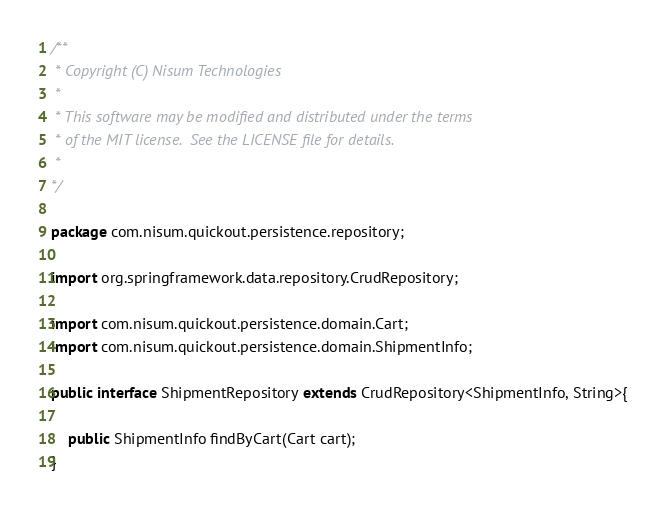Convert code to text. <code><loc_0><loc_0><loc_500><loc_500><_Java_>/**
 * Copyright (C) Nisum Technologies
 *
 * This software may be modified and distributed under the terms
 * of the MIT license.  See the LICENSE file for details.
 * 
*/

package com.nisum.quickout.persistence.repository;

import org.springframework.data.repository.CrudRepository;

import com.nisum.quickout.persistence.domain.Cart;
import com.nisum.quickout.persistence.domain.ShipmentInfo;

public interface ShipmentRepository extends CrudRepository<ShipmentInfo, String>{

	public ShipmentInfo findByCart(Cart cart);
}
</code> 